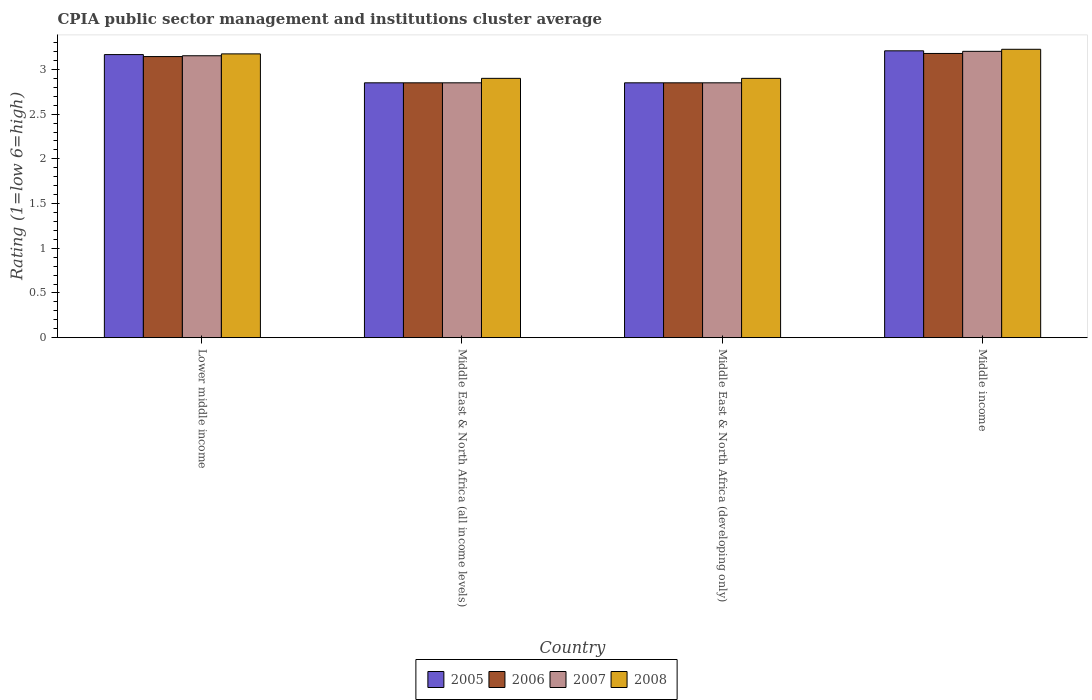How many different coloured bars are there?
Ensure brevity in your answer.  4. Are the number of bars on each tick of the X-axis equal?
Your response must be concise. Yes. In how many cases, is the number of bars for a given country not equal to the number of legend labels?
Keep it short and to the point. 0. What is the CPIA rating in 2007 in Middle income?
Ensure brevity in your answer.  3.2. Across all countries, what is the maximum CPIA rating in 2007?
Your answer should be very brief. 3.2. Across all countries, what is the minimum CPIA rating in 2005?
Give a very brief answer. 2.85. In which country was the CPIA rating in 2005 maximum?
Offer a terse response. Middle income. In which country was the CPIA rating in 2005 minimum?
Offer a very short reply. Middle East & North Africa (all income levels). What is the total CPIA rating in 2005 in the graph?
Give a very brief answer. 12.07. What is the difference between the CPIA rating in 2008 in Lower middle income and that in Middle East & North Africa (all income levels)?
Your answer should be very brief. 0.27. What is the difference between the CPIA rating in 2008 in Middle East & North Africa (developing only) and the CPIA rating in 2006 in Lower middle income?
Your answer should be very brief. -0.24. What is the average CPIA rating in 2007 per country?
Your answer should be compact. 3.01. In how many countries, is the CPIA rating in 2008 greater than 2.6?
Make the answer very short. 4. What is the ratio of the CPIA rating in 2005 in Lower middle income to that in Middle East & North Africa (developing only)?
Provide a succinct answer. 1.11. Is the CPIA rating in 2008 in Middle East & North Africa (all income levels) less than that in Middle East & North Africa (developing only)?
Make the answer very short. No. Is the difference between the CPIA rating in 2006 in Middle East & North Africa (developing only) and Middle income greater than the difference between the CPIA rating in 2007 in Middle East & North Africa (developing only) and Middle income?
Your answer should be compact. Yes. What is the difference between the highest and the second highest CPIA rating in 2008?
Your answer should be compact. 0.27. What is the difference between the highest and the lowest CPIA rating in 2007?
Your answer should be very brief. 0.35. What does the 1st bar from the right in Middle income represents?
Keep it short and to the point. 2008. Are all the bars in the graph horizontal?
Provide a succinct answer. No. How many countries are there in the graph?
Make the answer very short. 4. What is the difference between two consecutive major ticks on the Y-axis?
Ensure brevity in your answer.  0.5. Does the graph contain any zero values?
Give a very brief answer. No. Does the graph contain grids?
Provide a short and direct response. No. What is the title of the graph?
Give a very brief answer. CPIA public sector management and institutions cluster average. Does "1997" appear as one of the legend labels in the graph?
Provide a succinct answer. No. What is the label or title of the Y-axis?
Offer a terse response. Rating (1=low 6=high). What is the Rating (1=low 6=high) of 2005 in Lower middle income?
Ensure brevity in your answer.  3.17. What is the Rating (1=low 6=high) in 2006 in Lower middle income?
Make the answer very short. 3.14. What is the Rating (1=low 6=high) of 2007 in Lower middle income?
Offer a terse response. 3.15. What is the Rating (1=low 6=high) in 2008 in Lower middle income?
Your response must be concise. 3.17. What is the Rating (1=low 6=high) in 2005 in Middle East & North Africa (all income levels)?
Provide a succinct answer. 2.85. What is the Rating (1=low 6=high) of 2006 in Middle East & North Africa (all income levels)?
Your answer should be compact. 2.85. What is the Rating (1=low 6=high) of 2007 in Middle East & North Africa (all income levels)?
Ensure brevity in your answer.  2.85. What is the Rating (1=low 6=high) in 2008 in Middle East & North Africa (all income levels)?
Provide a succinct answer. 2.9. What is the Rating (1=low 6=high) of 2005 in Middle East & North Africa (developing only)?
Give a very brief answer. 2.85. What is the Rating (1=low 6=high) in 2006 in Middle East & North Africa (developing only)?
Make the answer very short. 2.85. What is the Rating (1=low 6=high) in 2007 in Middle East & North Africa (developing only)?
Offer a very short reply. 2.85. What is the Rating (1=low 6=high) in 2008 in Middle East & North Africa (developing only)?
Keep it short and to the point. 2.9. What is the Rating (1=low 6=high) in 2005 in Middle income?
Your answer should be very brief. 3.21. What is the Rating (1=low 6=high) of 2006 in Middle income?
Your answer should be compact. 3.18. What is the Rating (1=low 6=high) in 2007 in Middle income?
Your response must be concise. 3.2. What is the Rating (1=low 6=high) in 2008 in Middle income?
Offer a very short reply. 3.23. Across all countries, what is the maximum Rating (1=low 6=high) in 2005?
Your answer should be compact. 3.21. Across all countries, what is the maximum Rating (1=low 6=high) in 2006?
Your answer should be compact. 3.18. Across all countries, what is the maximum Rating (1=low 6=high) of 2007?
Make the answer very short. 3.2. Across all countries, what is the maximum Rating (1=low 6=high) of 2008?
Your answer should be compact. 3.23. Across all countries, what is the minimum Rating (1=low 6=high) of 2005?
Your response must be concise. 2.85. Across all countries, what is the minimum Rating (1=low 6=high) in 2006?
Your answer should be compact. 2.85. Across all countries, what is the minimum Rating (1=low 6=high) of 2007?
Keep it short and to the point. 2.85. Across all countries, what is the minimum Rating (1=low 6=high) of 2008?
Provide a short and direct response. 2.9. What is the total Rating (1=low 6=high) in 2005 in the graph?
Give a very brief answer. 12.07. What is the total Rating (1=low 6=high) of 2006 in the graph?
Keep it short and to the point. 12.02. What is the total Rating (1=low 6=high) in 2007 in the graph?
Ensure brevity in your answer.  12.05. What is the total Rating (1=low 6=high) of 2008 in the graph?
Make the answer very short. 12.2. What is the difference between the Rating (1=low 6=high) of 2005 in Lower middle income and that in Middle East & North Africa (all income levels)?
Give a very brief answer. 0.32. What is the difference between the Rating (1=low 6=high) in 2006 in Lower middle income and that in Middle East & North Africa (all income levels)?
Your answer should be compact. 0.29. What is the difference between the Rating (1=low 6=high) of 2007 in Lower middle income and that in Middle East & North Africa (all income levels)?
Provide a short and direct response. 0.3. What is the difference between the Rating (1=low 6=high) of 2008 in Lower middle income and that in Middle East & North Africa (all income levels)?
Make the answer very short. 0.27. What is the difference between the Rating (1=low 6=high) of 2005 in Lower middle income and that in Middle East & North Africa (developing only)?
Give a very brief answer. 0.32. What is the difference between the Rating (1=low 6=high) of 2006 in Lower middle income and that in Middle East & North Africa (developing only)?
Offer a very short reply. 0.29. What is the difference between the Rating (1=low 6=high) of 2007 in Lower middle income and that in Middle East & North Africa (developing only)?
Your response must be concise. 0.3. What is the difference between the Rating (1=low 6=high) of 2008 in Lower middle income and that in Middle East & North Africa (developing only)?
Provide a succinct answer. 0.27. What is the difference between the Rating (1=low 6=high) in 2005 in Lower middle income and that in Middle income?
Offer a very short reply. -0.04. What is the difference between the Rating (1=low 6=high) in 2006 in Lower middle income and that in Middle income?
Provide a short and direct response. -0.03. What is the difference between the Rating (1=low 6=high) in 2007 in Lower middle income and that in Middle income?
Offer a very short reply. -0.05. What is the difference between the Rating (1=low 6=high) in 2008 in Lower middle income and that in Middle income?
Provide a succinct answer. -0.05. What is the difference between the Rating (1=low 6=high) in 2005 in Middle East & North Africa (all income levels) and that in Middle East & North Africa (developing only)?
Keep it short and to the point. 0. What is the difference between the Rating (1=low 6=high) of 2006 in Middle East & North Africa (all income levels) and that in Middle East & North Africa (developing only)?
Your response must be concise. 0. What is the difference between the Rating (1=low 6=high) in 2008 in Middle East & North Africa (all income levels) and that in Middle East & North Africa (developing only)?
Provide a short and direct response. 0. What is the difference between the Rating (1=low 6=high) of 2005 in Middle East & North Africa (all income levels) and that in Middle income?
Your answer should be compact. -0.36. What is the difference between the Rating (1=low 6=high) in 2006 in Middle East & North Africa (all income levels) and that in Middle income?
Ensure brevity in your answer.  -0.33. What is the difference between the Rating (1=low 6=high) of 2007 in Middle East & North Africa (all income levels) and that in Middle income?
Provide a succinct answer. -0.35. What is the difference between the Rating (1=low 6=high) in 2008 in Middle East & North Africa (all income levels) and that in Middle income?
Offer a terse response. -0.33. What is the difference between the Rating (1=low 6=high) of 2005 in Middle East & North Africa (developing only) and that in Middle income?
Provide a succinct answer. -0.36. What is the difference between the Rating (1=low 6=high) of 2006 in Middle East & North Africa (developing only) and that in Middle income?
Make the answer very short. -0.33. What is the difference between the Rating (1=low 6=high) in 2007 in Middle East & North Africa (developing only) and that in Middle income?
Offer a terse response. -0.35. What is the difference between the Rating (1=low 6=high) in 2008 in Middle East & North Africa (developing only) and that in Middle income?
Provide a short and direct response. -0.33. What is the difference between the Rating (1=low 6=high) in 2005 in Lower middle income and the Rating (1=low 6=high) in 2006 in Middle East & North Africa (all income levels)?
Make the answer very short. 0.32. What is the difference between the Rating (1=low 6=high) of 2005 in Lower middle income and the Rating (1=low 6=high) of 2007 in Middle East & North Africa (all income levels)?
Provide a succinct answer. 0.32. What is the difference between the Rating (1=low 6=high) in 2005 in Lower middle income and the Rating (1=low 6=high) in 2008 in Middle East & North Africa (all income levels)?
Offer a very short reply. 0.27. What is the difference between the Rating (1=low 6=high) of 2006 in Lower middle income and the Rating (1=low 6=high) of 2007 in Middle East & North Africa (all income levels)?
Offer a terse response. 0.29. What is the difference between the Rating (1=low 6=high) of 2006 in Lower middle income and the Rating (1=low 6=high) of 2008 in Middle East & North Africa (all income levels)?
Offer a terse response. 0.24. What is the difference between the Rating (1=low 6=high) in 2007 in Lower middle income and the Rating (1=low 6=high) in 2008 in Middle East & North Africa (all income levels)?
Keep it short and to the point. 0.25. What is the difference between the Rating (1=low 6=high) in 2005 in Lower middle income and the Rating (1=low 6=high) in 2006 in Middle East & North Africa (developing only)?
Provide a succinct answer. 0.32. What is the difference between the Rating (1=low 6=high) in 2005 in Lower middle income and the Rating (1=low 6=high) in 2007 in Middle East & North Africa (developing only)?
Keep it short and to the point. 0.32. What is the difference between the Rating (1=low 6=high) in 2005 in Lower middle income and the Rating (1=low 6=high) in 2008 in Middle East & North Africa (developing only)?
Provide a succinct answer. 0.27. What is the difference between the Rating (1=low 6=high) in 2006 in Lower middle income and the Rating (1=low 6=high) in 2007 in Middle East & North Africa (developing only)?
Your answer should be compact. 0.29. What is the difference between the Rating (1=low 6=high) in 2006 in Lower middle income and the Rating (1=low 6=high) in 2008 in Middle East & North Africa (developing only)?
Provide a succinct answer. 0.24. What is the difference between the Rating (1=low 6=high) in 2007 in Lower middle income and the Rating (1=low 6=high) in 2008 in Middle East & North Africa (developing only)?
Your answer should be compact. 0.25. What is the difference between the Rating (1=low 6=high) of 2005 in Lower middle income and the Rating (1=low 6=high) of 2006 in Middle income?
Offer a terse response. -0.01. What is the difference between the Rating (1=low 6=high) of 2005 in Lower middle income and the Rating (1=low 6=high) of 2007 in Middle income?
Ensure brevity in your answer.  -0.04. What is the difference between the Rating (1=low 6=high) in 2005 in Lower middle income and the Rating (1=low 6=high) in 2008 in Middle income?
Provide a short and direct response. -0.06. What is the difference between the Rating (1=low 6=high) of 2006 in Lower middle income and the Rating (1=low 6=high) of 2007 in Middle income?
Offer a terse response. -0.06. What is the difference between the Rating (1=low 6=high) in 2006 in Lower middle income and the Rating (1=low 6=high) in 2008 in Middle income?
Provide a succinct answer. -0.08. What is the difference between the Rating (1=low 6=high) of 2007 in Lower middle income and the Rating (1=low 6=high) of 2008 in Middle income?
Keep it short and to the point. -0.07. What is the difference between the Rating (1=low 6=high) in 2005 in Middle East & North Africa (all income levels) and the Rating (1=low 6=high) in 2006 in Middle East & North Africa (developing only)?
Ensure brevity in your answer.  0. What is the difference between the Rating (1=low 6=high) of 2005 in Middle East & North Africa (all income levels) and the Rating (1=low 6=high) of 2007 in Middle East & North Africa (developing only)?
Ensure brevity in your answer.  0. What is the difference between the Rating (1=low 6=high) in 2006 in Middle East & North Africa (all income levels) and the Rating (1=low 6=high) in 2007 in Middle East & North Africa (developing only)?
Ensure brevity in your answer.  0. What is the difference between the Rating (1=low 6=high) in 2006 in Middle East & North Africa (all income levels) and the Rating (1=low 6=high) in 2008 in Middle East & North Africa (developing only)?
Your response must be concise. -0.05. What is the difference between the Rating (1=low 6=high) of 2007 in Middle East & North Africa (all income levels) and the Rating (1=low 6=high) of 2008 in Middle East & North Africa (developing only)?
Give a very brief answer. -0.05. What is the difference between the Rating (1=low 6=high) of 2005 in Middle East & North Africa (all income levels) and the Rating (1=low 6=high) of 2006 in Middle income?
Provide a short and direct response. -0.33. What is the difference between the Rating (1=low 6=high) of 2005 in Middle East & North Africa (all income levels) and the Rating (1=low 6=high) of 2007 in Middle income?
Your answer should be compact. -0.35. What is the difference between the Rating (1=low 6=high) of 2005 in Middle East & North Africa (all income levels) and the Rating (1=low 6=high) of 2008 in Middle income?
Your response must be concise. -0.38. What is the difference between the Rating (1=low 6=high) in 2006 in Middle East & North Africa (all income levels) and the Rating (1=low 6=high) in 2007 in Middle income?
Keep it short and to the point. -0.35. What is the difference between the Rating (1=low 6=high) in 2006 in Middle East & North Africa (all income levels) and the Rating (1=low 6=high) in 2008 in Middle income?
Your answer should be compact. -0.38. What is the difference between the Rating (1=low 6=high) of 2007 in Middle East & North Africa (all income levels) and the Rating (1=low 6=high) of 2008 in Middle income?
Provide a short and direct response. -0.38. What is the difference between the Rating (1=low 6=high) of 2005 in Middle East & North Africa (developing only) and the Rating (1=low 6=high) of 2006 in Middle income?
Make the answer very short. -0.33. What is the difference between the Rating (1=low 6=high) of 2005 in Middle East & North Africa (developing only) and the Rating (1=low 6=high) of 2007 in Middle income?
Make the answer very short. -0.35. What is the difference between the Rating (1=low 6=high) in 2005 in Middle East & North Africa (developing only) and the Rating (1=low 6=high) in 2008 in Middle income?
Offer a very short reply. -0.38. What is the difference between the Rating (1=low 6=high) in 2006 in Middle East & North Africa (developing only) and the Rating (1=low 6=high) in 2007 in Middle income?
Your answer should be compact. -0.35. What is the difference between the Rating (1=low 6=high) of 2006 in Middle East & North Africa (developing only) and the Rating (1=low 6=high) of 2008 in Middle income?
Offer a very short reply. -0.38. What is the difference between the Rating (1=low 6=high) of 2007 in Middle East & North Africa (developing only) and the Rating (1=low 6=high) of 2008 in Middle income?
Offer a terse response. -0.38. What is the average Rating (1=low 6=high) of 2005 per country?
Provide a succinct answer. 3.02. What is the average Rating (1=low 6=high) of 2006 per country?
Keep it short and to the point. 3.01. What is the average Rating (1=low 6=high) in 2007 per country?
Your response must be concise. 3.01. What is the average Rating (1=low 6=high) of 2008 per country?
Offer a very short reply. 3.05. What is the difference between the Rating (1=low 6=high) of 2005 and Rating (1=low 6=high) of 2006 in Lower middle income?
Offer a very short reply. 0.02. What is the difference between the Rating (1=low 6=high) in 2005 and Rating (1=low 6=high) in 2007 in Lower middle income?
Offer a very short reply. 0.01. What is the difference between the Rating (1=low 6=high) of 2005 and Rating (1=low 6=high) of 2008 in Lower middle income?
Provide a succinct answer. -0.01. What is the difference between the Rating (1=low 6=high) in 2006 and Rating (1=low 6=high) in 2007 in Lower middle income?
Your response must be concise. -0.01. What is the difference between the Rating (1=low 6=high) of 2006 and Rating (1=low 6=high) of 2008 in Lower middle income?
Offer a terse response. -0.03. What is the difference between the Rating (1=low 6=high) of 2007 and Rating (1=low 6=high) of 2008 in Lower middle income?
Your response must be concise. -0.02. What is the difference between the Rating (1=low 6=high) of 2006 and Rating (1=low 6=high) of 2007 in Middle East & North Africa (all income levels)?
Your answer should be compact. 0. What is the difference between the Rating (1=low 6=high) in 2006 and Rating (1=low 6=high) in 2008 in Middle East & North Africa (all income levels)?
Your answer should be very brief. -0.05. What is the difference between the Rating (1=low 6=high) of 2007 and Rating (1=low 6=high) of 2008 in Middle East & North Africa (all income levels)?
Offer a terse response. -0.05. What is the difference between the Rating (1=low 6=high) of 2006 and Rating (1=low 6=high) of 2007 in Middle East & North Africa (developing only)?
Keep it short and to the point. 0. What is the difference between the Rating (1=low 6=high) of 2007 and Rating (1=low 6=high) of 2008 in Middle East & North Africa (developing only)?
Give a very brief answer. -0.05. What is the difference between the Rating (1=low 6=high) in 2005 and Rating (1=low 6=high) in 2006 in Middle income?
Your answer should be compact. 0.03. What is the difference between the Rating (1=low 6=high) of 2005 and Rating (1=low 6=high) of 2007 in Middle income?
Give a very brief answer. 0.01. What is the difference between the Rating (1=low 6=high) of 2005 and Rating (1=low 6=high) of 2008 in Middle income?
Provide a succinct answer. -0.02. What is the difference between the Rating (1=low 6=high) in 2006 and Rating (1=low 6=high) in 2007 in Middle income?
Ensure brevity in your answer.  -0.02. What is the difference between the Rating (1=low 6=high) in 2006 and Rating (1=low 6=high) in 2008 in Middle income?
Provide a succinct answer. -0.05. What is the difference between the Rating (1=low 6=high) in 2007 and Rating (1=low 6=high) in 2008 in Middle income?
Your answer should be compact. -0.02. What is the ratio of the Rating (1=low 6=high) in 2005 in Lower middle income to that in Middle East & North Africa (all income levels)?
Provide a succinct answer. 1.11. What is the ratio of the Rating (1=low 6=high) of 2006 in Lower middle income to that in Middle East & North Africa (all income levels)?
Your response must be concise. 1.1. What is the ratio of the Rating (1=low 6=high) in 2007 in Lower middle income to that in Middle East & North Africa (all income levels)?
Your response must be concise. 1.11. What is the ratio of the Rating (1=low 6=high) in 2008 in Lower middle income to that in Middle East & North Africa (all income levels)?
Provide a succinct answer. 1.09. What is the ratio of the Rating (1=low 6=high) in 2005 in Lower middle income to that in Middle East & North Africa (developing only)?
Your response must be concise. 1.11. What is the ratio of the Rating (1=low 6=high) of 2006 in Lower middle income to that in Middle East & North Africa (developing only)?
Provide a short and direct response. 1.1. What is the ratio of the Rating (1=low 6=high) in 2007 in Lower middle income to that in Middle East & North Africa (developing only)?
Keep it short and to the point. 1.11. What is the ratio of the Rating (1=low 6=high) of 2008 in Lower middle income to that in Middle East & North Africa (developing only)?
Your answer should be very brief. 1.09. What is the ratio of the Rating (1=low 6=high) in 2007 in Lower middle income to that in Middle income?
Give a very brief answer. 0.98. What is the ratio of the Rating (1=low 6=high) of 2008 in Lower middle income to that in Middle income?
Give a very brief answer. 0.98. What is the ratio of the Rating (1=low 6=high) in 2007 in Middle East & North Africa (all income levels) to that in Middle East & North Africa (developing only)?
Offer a very short reply. 1. What is the ratio of the Rating (1=low 6=high) in 2005 in Middle East & North Africa (all income levels) to that in Middle income?
Provide a succinct answer. 0.89. What is the ratio of the Rating (1=low 6=high) of 2006 in Middle East & North Africa (all income levels) to that in Middle income?
Provide a succinct answer. 0.9. What is the ratio of the Rating (1=low 6=high) of 2007 in Middle East & North Africa (all income levels) to that in Middle income?
Make the answer very short. 0.89. What is the ratio of the Rating (1=low 6=high) in 2008 in Middle East & North Africa (all income levels) to that in Middle income?
Offer a very short reply. 0.9. What is the ratio of the Rating (1=low 6=high) of 2005 in Middle East & North Africa (developing only) to that in Middle income?
Your answer should be compact. 0.89. What is the ratio of the Rating (1=low 6=high) in 2006 in Middle East & North Africa (developing only) to that in Middle income?
Offer a terse response. 0.9. What is the ratio of the Rating (1=low 6=high) of 2007 in Middle East & North Africa (developing only) to that in Middle income?
Your response must be concise. 0.89. What is the ratio of the Rating (1=low 6=high) in 2008 in Middle East & North Africa (developing only) to that in Middle income?
Your answer should be compact. 0.9. What is the difference between the highest and the second highest Rating (1=low 6=high) of 2005?
Make the answer very short. 0.04. What is the difference between the highest and the second highest Rating (1=low 6=high) of 2006?
Offer a terse response. 0.03. What is the difference between the highest and the second highest Rating (1=low 6=high) of 2007?
Your answer should be very brief. 0.05. What is the difference between the highest and the second highest Rating (1=low 6=high) of 2008?
Offer a terse response. 0.05. What is the difference between the highest and the lowest Rating (1=low 6=high) of 2005?
Ensure brevity in your answer.  0.36. What is the difference between the highest and the lowest Rating (1=low 6=high) of 2006?
Offer a very short reply. 0.33. What is the difference between the highest and the lowest Rating (1=low 6=high) in 2007?
Offer a terse response. 0.35. What is the difference between the highest and the lowest Rating (1=low 6=high) of 2008?
Make the answer very short. 0.33. 